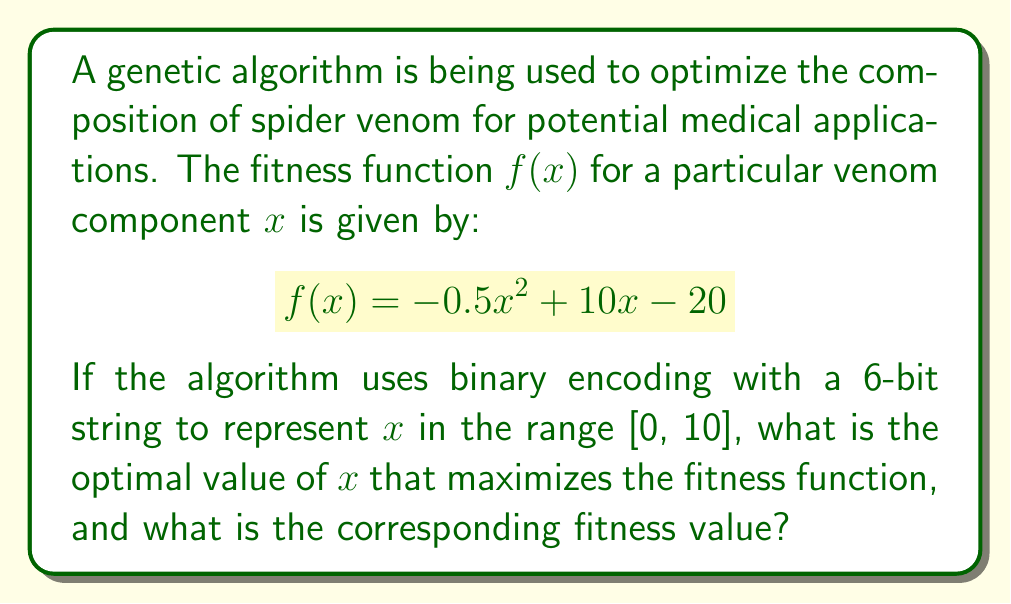Teach me how to tackle this problem. To solve this problem, we'll follow these steps:

1) First, we need to find the maximum of the fitness function $f(x) = -0.5x^2 + 10x - 20$. This is a quadratic function, and its maximum can be found at the vertex of the parabola.

2) To find the vertex, we can use the formula $x = -b/(2a)$ where $a$ and $b$ are the coefficients of the quadratic function in the form $ax^2 + bx + c$.

   $a = -0.5$, $b = 10$

   $x = -10/(2(-0.5)) = 10$

3) However, we need to check if this value is within our range [0, 10]. Since 10 is at the upper bound of our range, it's a valid solution.

4) Now, we need to determine how this value is represented in the 6-bit binary encoding. With 6 bits, we can represent $2^6 = 64$ different values. To map these to the range [0, 10], each increment in the binary number represents an increase of $10/63 \approx 0.15873$ in the real number.

5) The binary representation closest to 10 would be 111111 (63 in decimal), which maps to:

   $63 * (10/63) = 10$

6) To find the fitness value, we substitute $x = 10$ into the fitness function:

   $f(10) = -0.5(10)^2 + 10(10) - 20$
          $= -50 + 100 - 20$
          $= 30$

Therefore, the optimal value of $x$ is 10, represented as 111111 in the 6-bit encoding, and the corresponding maximum fitness value is 30.
Answer: Optimal value of $x$: 10 (binary: 111111)
Maximum fitness value: 30 